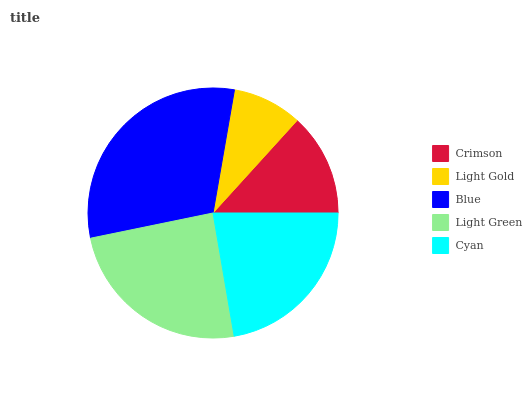Is Light Gold the minimum?
Answer yes or no. Yes. Is Blue the maximum?
Answer yes or no. Yes. Is Blue the minimum?
Answer yes or no. No. Is Light Gold the maximum?
Answer yes or no. No. Is Blue greater than Light Gold?
Answer yes or no. Yes. Is Light Gold less than Blue?
Answer yes or no. Yes. Is Light Gold greater than Blue?
Answer yes or no. No. Is Blue less than Light Gold?
Answer yes or no. No. Is Cyan the high median?
Answer yes or no. Yes. Is Cyan the low median?
Answer yes or no. Yes. Is Blue the high median?
Answer yes or no. No. Is Crimson the low median?
Answer yes or no. No. 